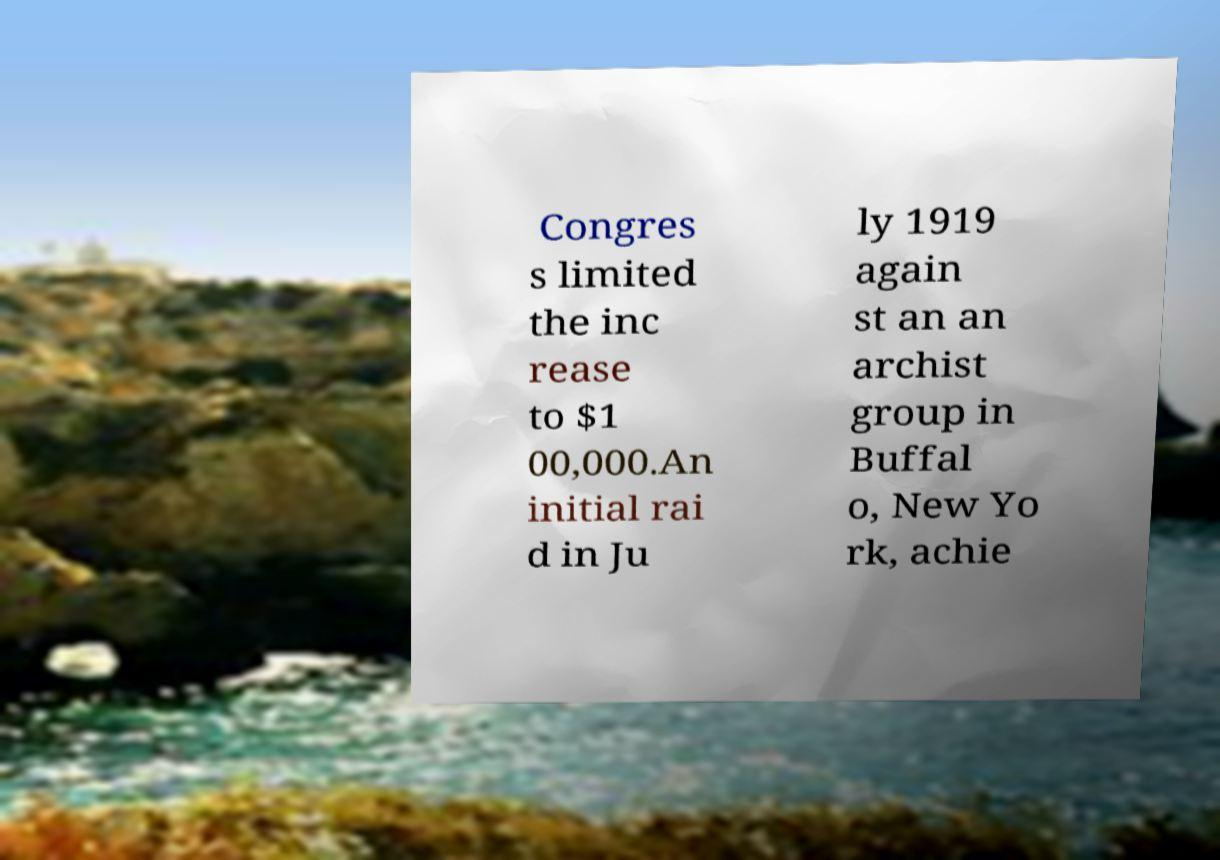Can you read and provide the text displayed in the image?This photo seems to have some interesting text. Can you extract and type it out for me? Congres s limited the inc rease to $1 00,000.An initial rai d in Ju ly 1919 again st an an archist group in Buffal o, New Yo rk, achie 